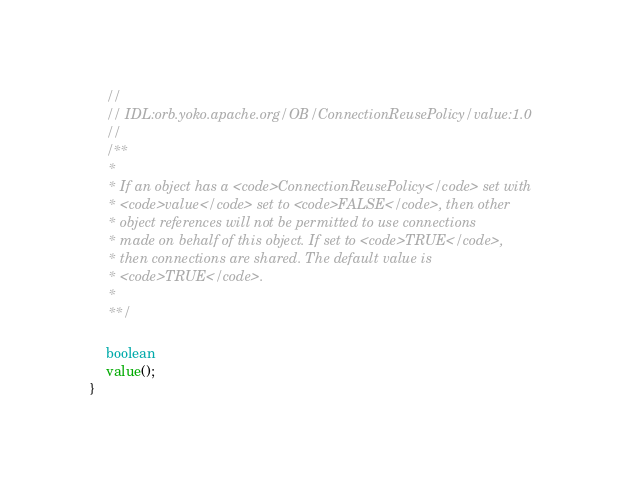Convert code to text. <code><loc_0><loc_0><loc_500><loc_500><_Java_>    //
    // IDL:orb.yoko.apache.org/OB/ConnectionReusePolicy/value:1.0
    //
    /**
     *
     * If an object has a <code>ConnectionReusePolicy</code> set with
     * <code>value</code> set to <code>FALSE</code>, then other
     * object references will not be permitted to use connections
     * made on behalf of this object. If set to <code>TRUE</code>,
     * then connections are shared. The default value is
     * <code>TRUE</code>.
     *
     **/

    boolean
    value();
}
</code> 